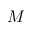Convert formula to latex. <formula><loc_0><loc_0><loc_500><loc_500>M</formula> 